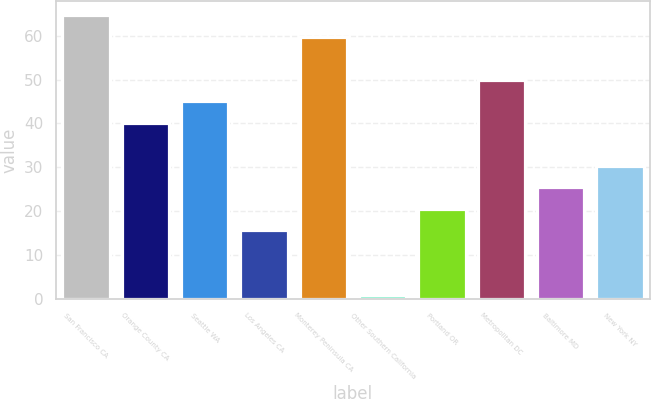<chart> <loc_0><loc_0><loc_500><loc_500><bar_chart><fcel>San Francisco CA<fcel>Orange County CA<fcel>Seattle WA<fcel>Los Angeles CA<fcel>Monterey Peninsula CA<fcel>Other Southern California<fcel>Portland OR<fcel>Metropolitan DC<fcel>Baltimore MD<fcel>New York NY<nl><fcel>64.7<fcel>40.2<fcel>45.1<fcel>15.7<fcel>59.8<fcel>1<fcel>20.6<fcel>50<fcel>25.5<fcel>30.4<nl></chart> 